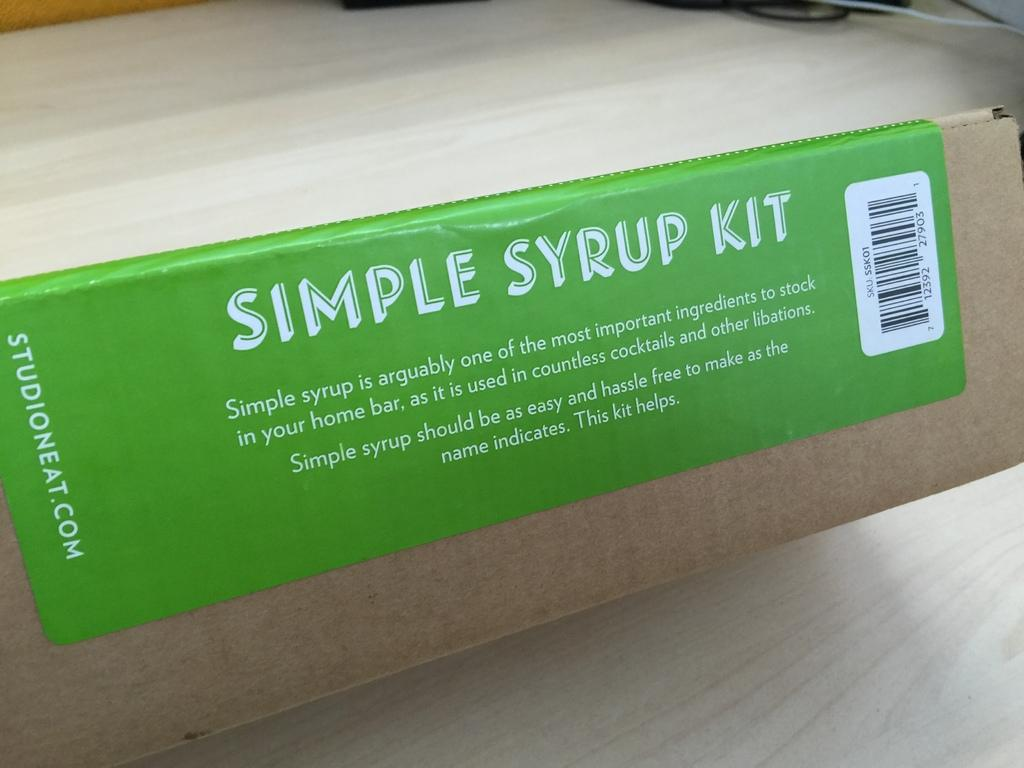What is the color of the sticker in the image? The sticker in the image is green. What is the sticker attached to? The green sticker is attached to a carton. How does the nerve react to the green sticker in the image? There is no nerve present in the image, so it cannot react to the green sticker. 